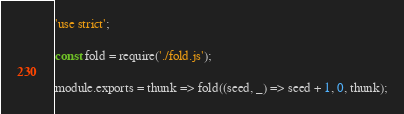<code> <loc_0><loc_0><loc_500><loc_500><_JavaScript_>'use strict';

const fold = require('./fold.js');

module.exports = thunk => fold((seed, _) => seed + 1, 0, thunk);
</code> 